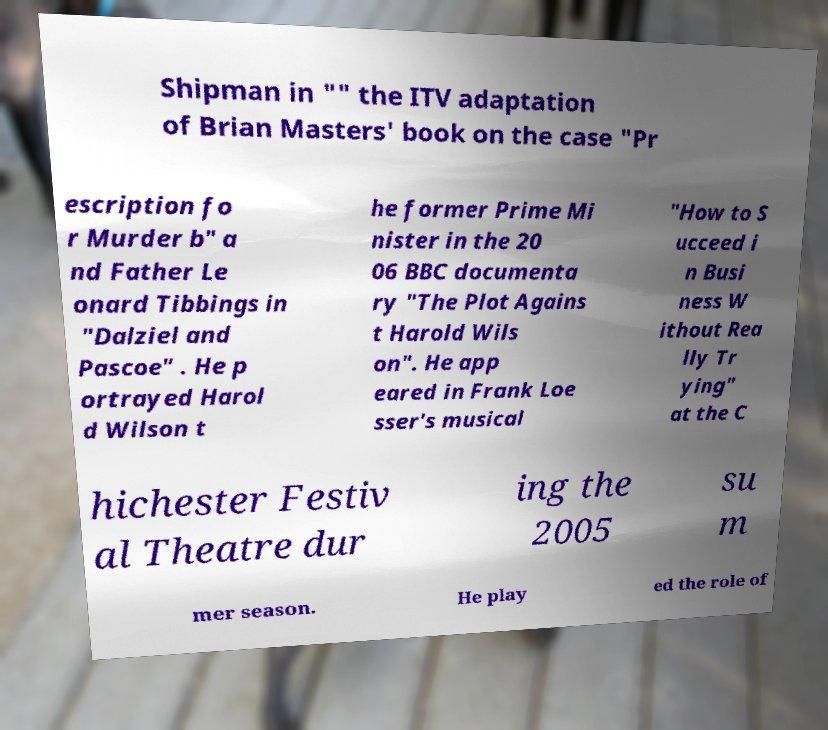What messages or text are displayed in this image? I need them in a readable, typed format. Shipman in "" the ITV adaptation of Brian Masters' book on the case "Pr escription fo r Murder b" a nd Father Le onard Tibbings in "Dalziel and Pascoe" . He p ortrayed Harol d Wilson t he former Prime Mi nister in the 20 06 BBC documenta ry "The Plot Agains t Harold Wils on". He app eared in Frank Loe sser's musical "How to S ucceed i n Busi ness W ithout Rea lly Tr ying" at the C hichester Festiv al Theatre dur ing the 2005 su m mer season. He play ed the role of 